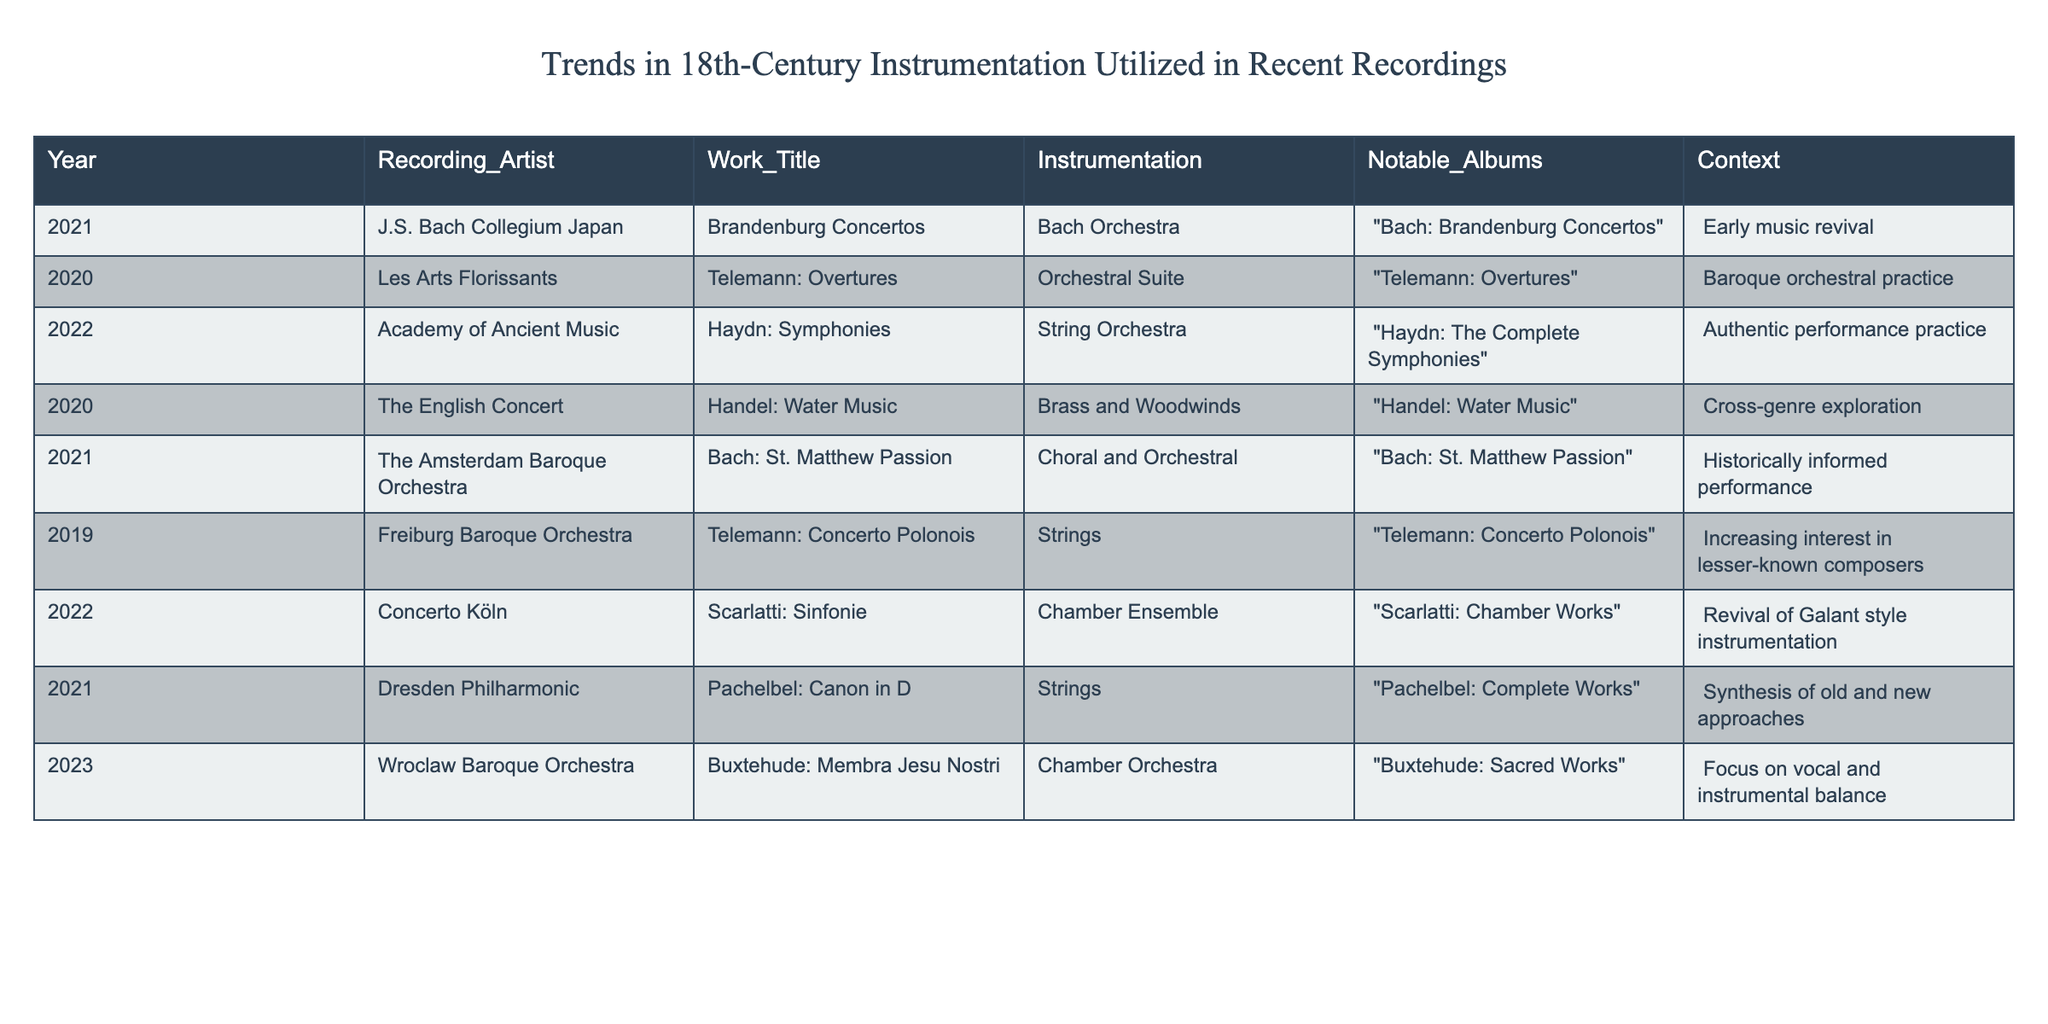What is the instrumentation used in the 2022 recording of Haydn's Symphonies? The table shows that the instrumentation for Haydn's Symphonies recorded in 2022 is a String Orchestra.
Answer: String Orchestra Which recording artist performed Telemann's Overtures in 2020? According to the table, Les Arts Florissants performed Telemann's Overtures in 2020.
Answer: Les Arts Florissants How many recordings feature a Chamber Ensemble as instrumentation? The table lists one recording with a Chamber Ensemble, which is Scarlatti: Sinfonie in 2022, hence the total is 1.
Answer: 1 Did the Wroclaw Baroque Orchestra focus on vocal and instrumental balance in their 2023 recording? True, the table indicates that Wroclaw Baroque Orchestra's recording of Buxtehude: Membra Jesu Nostri in 2023 had a focus on vocal and instrumental balance.
Answer: True Which instrumentation appears most frequently in the table? Analyzing the table, it shows Strings appear in three records (Pachelbel: Canon in D, Telemann: Concerto Polonois, and Haydn: Symphonies) making it the most frequent instrumentation.
Answer: Strings What is the context of the 2021 recording titled "Bach: St. Matthew Passion"? The context listed for the recording "Bach: St. Matthew Passion" in 2021 is historically informed performance.
Answer: Historically informed performance How many different years are represented in the table? The years represented in the table are 2019, 2020, 2021, 2022, and 2023. That's a total of 5 unique years.
Answer: 5 Which artist recorded under the context of "Increasing interest in lesser-known composers" and what was the work? The Freiburg Baroque Orchestra recorded Telemann: Concerto Polonois under the context of "Increasing interest in lesser-known composers."
Answer: Freiburg Baroque Orchestra; Telemann: Concerto Polonois What is the relationship between the context "Cross-genre exploration" and its listed work? The context "Cross-genre exploration" relates to the 2020 work "Handel: Water Music" performed by The English Concert, indicating the exploration of musical styles.
Answer: Cross-genre exploration is related to "Handel: Water Music" How does the instrumentation of the recordings in 2021 compare to those in 2022? In 2021, the instrumentation includes Bach Orchestra, Brass and Woodwinds, and Choral and Orchestral, while in 2022, it includes String Orchestra and Chamber Ensemble. The diversity of instrumentation suggests varied approaches across the years.
Answer: The instrumentation varies, indicating different approaches 